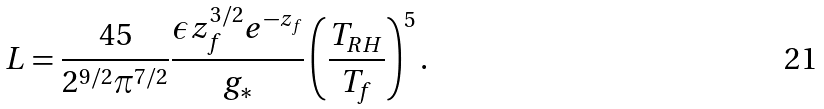Convert formula to latex. <formula><loc_0><loc_0><loc_500><loc_500>L = \frac { 4 5 } { 2 ^ { 9 / 2 } \pi ^ { 7 / 2 } } \frac { \epsilon z _ { f } ^ { 3 / 2 } e ^ { - z _ { f } } } { g _ { * } } \left ( \frac { T _ { R H } } { T _ { f } } \right ) ^ { 5 } .</formula> 